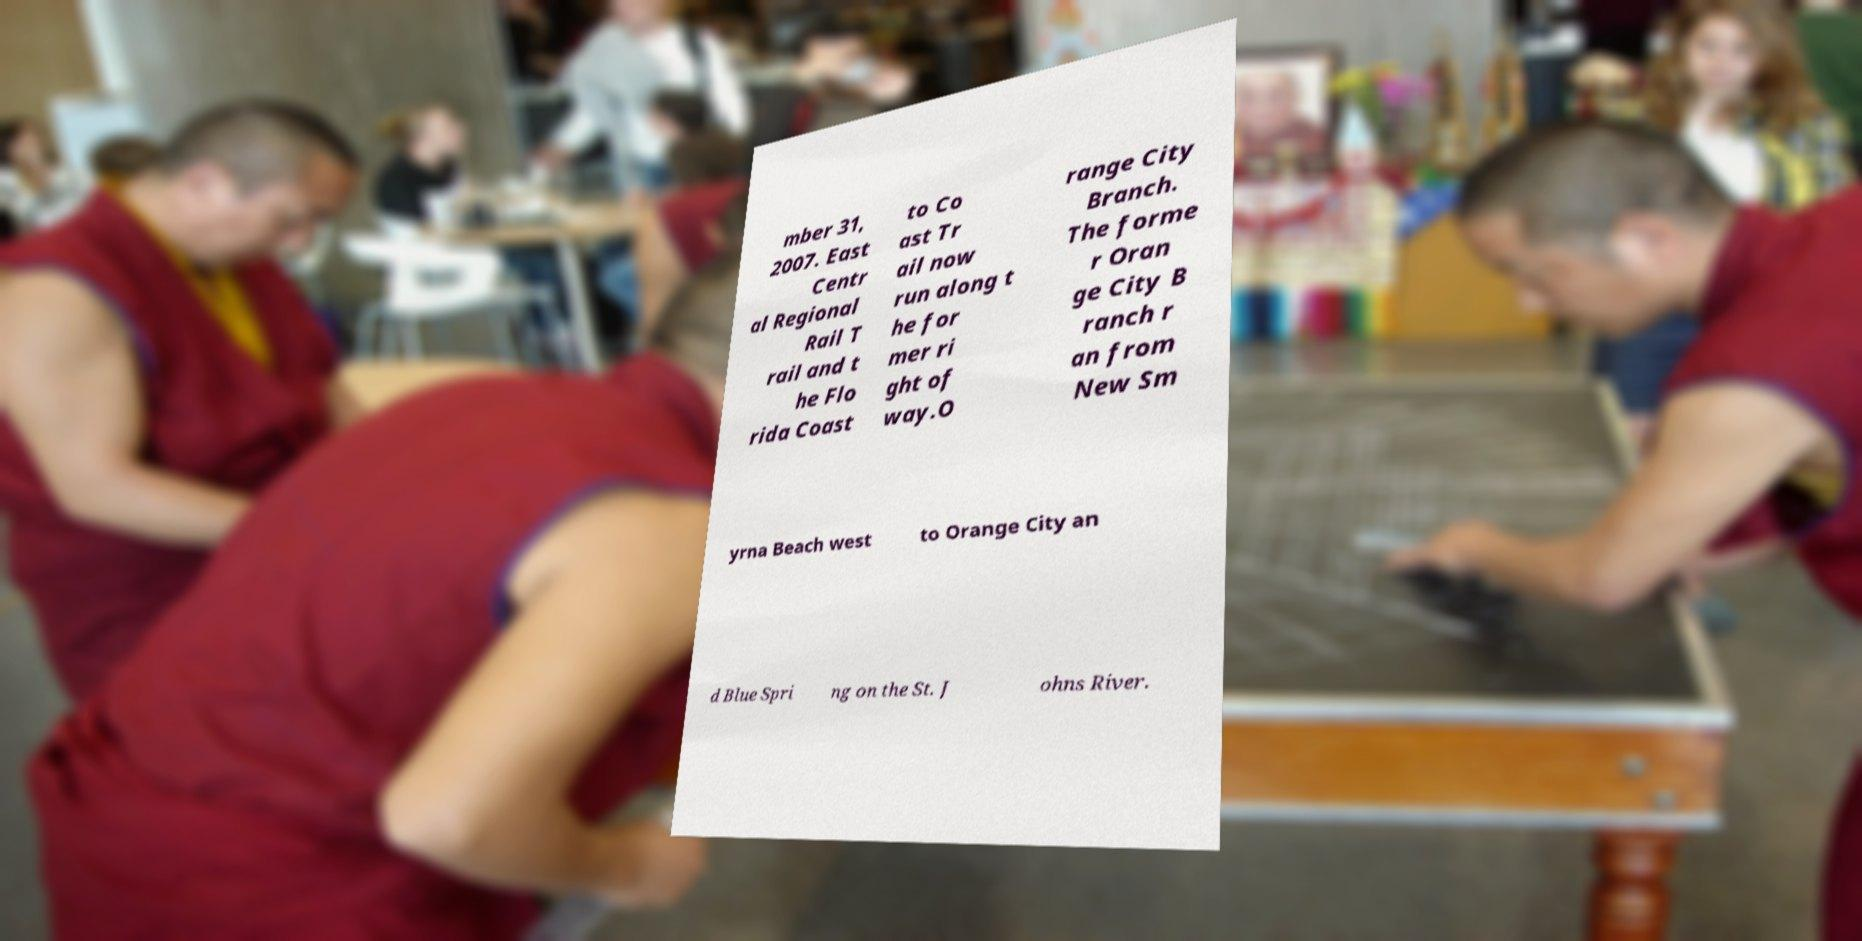Please identify and transcribe the text found in this image. mber 31, 2007. East Centr al Regional Rail T rail and t he Flo rida Coast to Co ast Tr ail now run along t he for mer ri ght of way.O range City Branch. The forme r Oran ge City B ranch r an from New Sm yrna Beach west to Orange City an d Blue Spri ng on the St. J ohns River. 